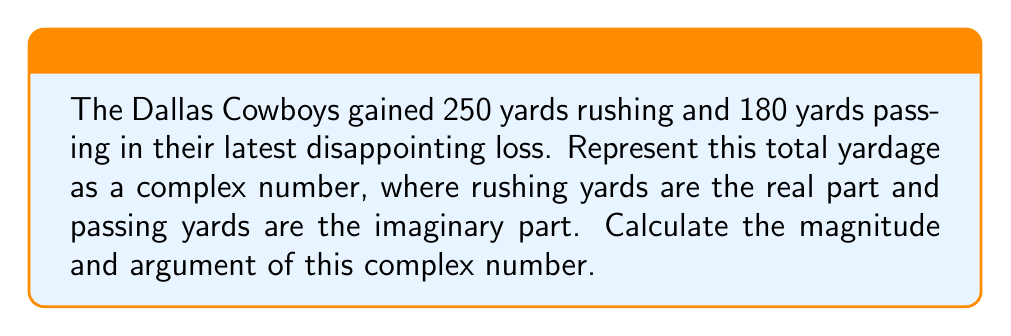Help me with this question. Let's approach this step-by-step:

1) First, we represent the total yardage as a complex number:
   $z = 250 + 180i$

2) To find the magnitude, we use the formula:
   $|z| = \sqrt{a^2 + b^2}$, where $a$ is the real part and $b$ is the imaginary part.

   $|z| = \sqrt{250^2 + 180^2}$
   $|z| = \sqrt{62500 + 32400}$
   $|z| = \sqrt{94900}$
   $|z| \approx 308.06$ yards

3) To find the argument, we use the formula:
   $\arg(z) = \tan^{-1}(\frac{b}{a})$

   $\arg(z) = \tan^{-1}(\frac{180}{250})$
   $\arg(z) \approx 0.6235$ radians

4) To convert radians to degrees:
   $0.6235 \cdot \frac{180^{\circ}}{\pi} \approx 35.71^{\circ}$

The magnitude represents the total yardage gained, while the argument represents the angle of the team's offensive strategy (higher angle means more pass-heavy).
Answer: Magnitude: $308.06$ yards, Argument: $35.71^{\circ}$ 